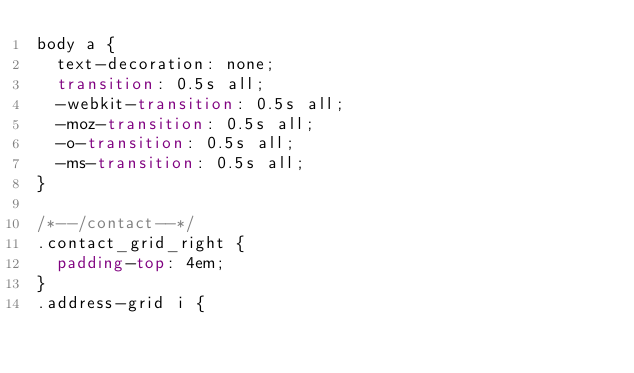<code> <loc_0><loc_0><loc_500><loc_500><_CSS_>body a {
  text-decoration: none;
  transition: 0.5s all;
  -webkit-transition: 0.5s all;
  -moz-transition: 0.5s all;
  -o-transition: 0.5s all;
  -ms-transition: 0.5s all;
}

/*--/contact--*/
.contact_grid_right {
  padding-top: 4em;
}
.address-grid i {</code> 